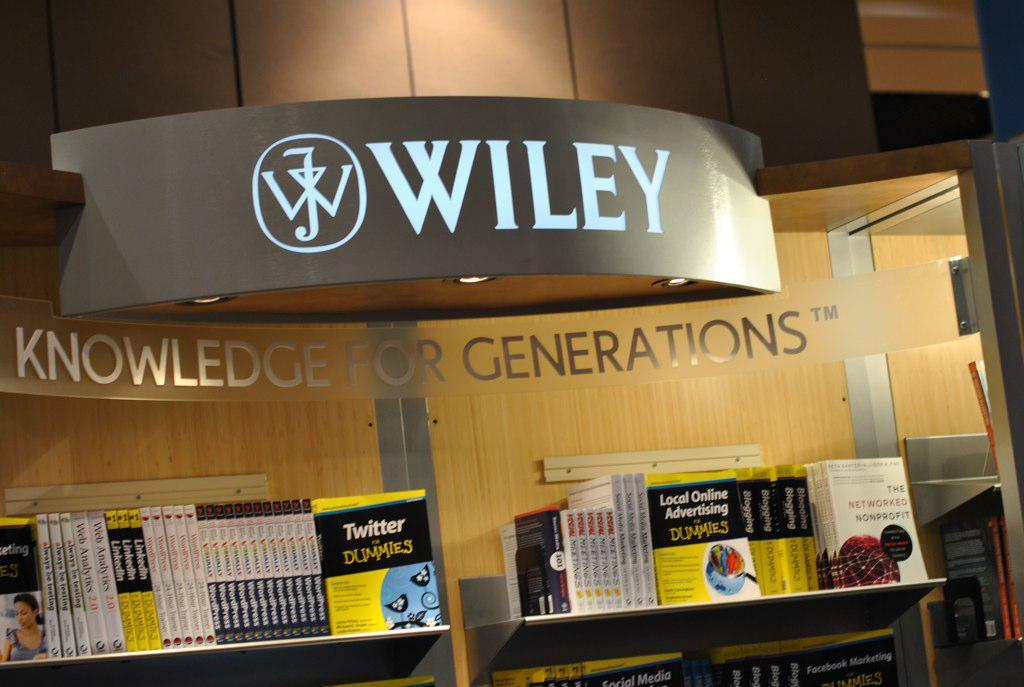What is the main structure visible in the image? There is a building in the image. What is written on the building? There is text written on the building. Where can books be found in the image? Books are in a shelf in the image. How many people are sleeping on the roof of the building in the image? There is no information about people sleeping on the roof of the building in the image. 